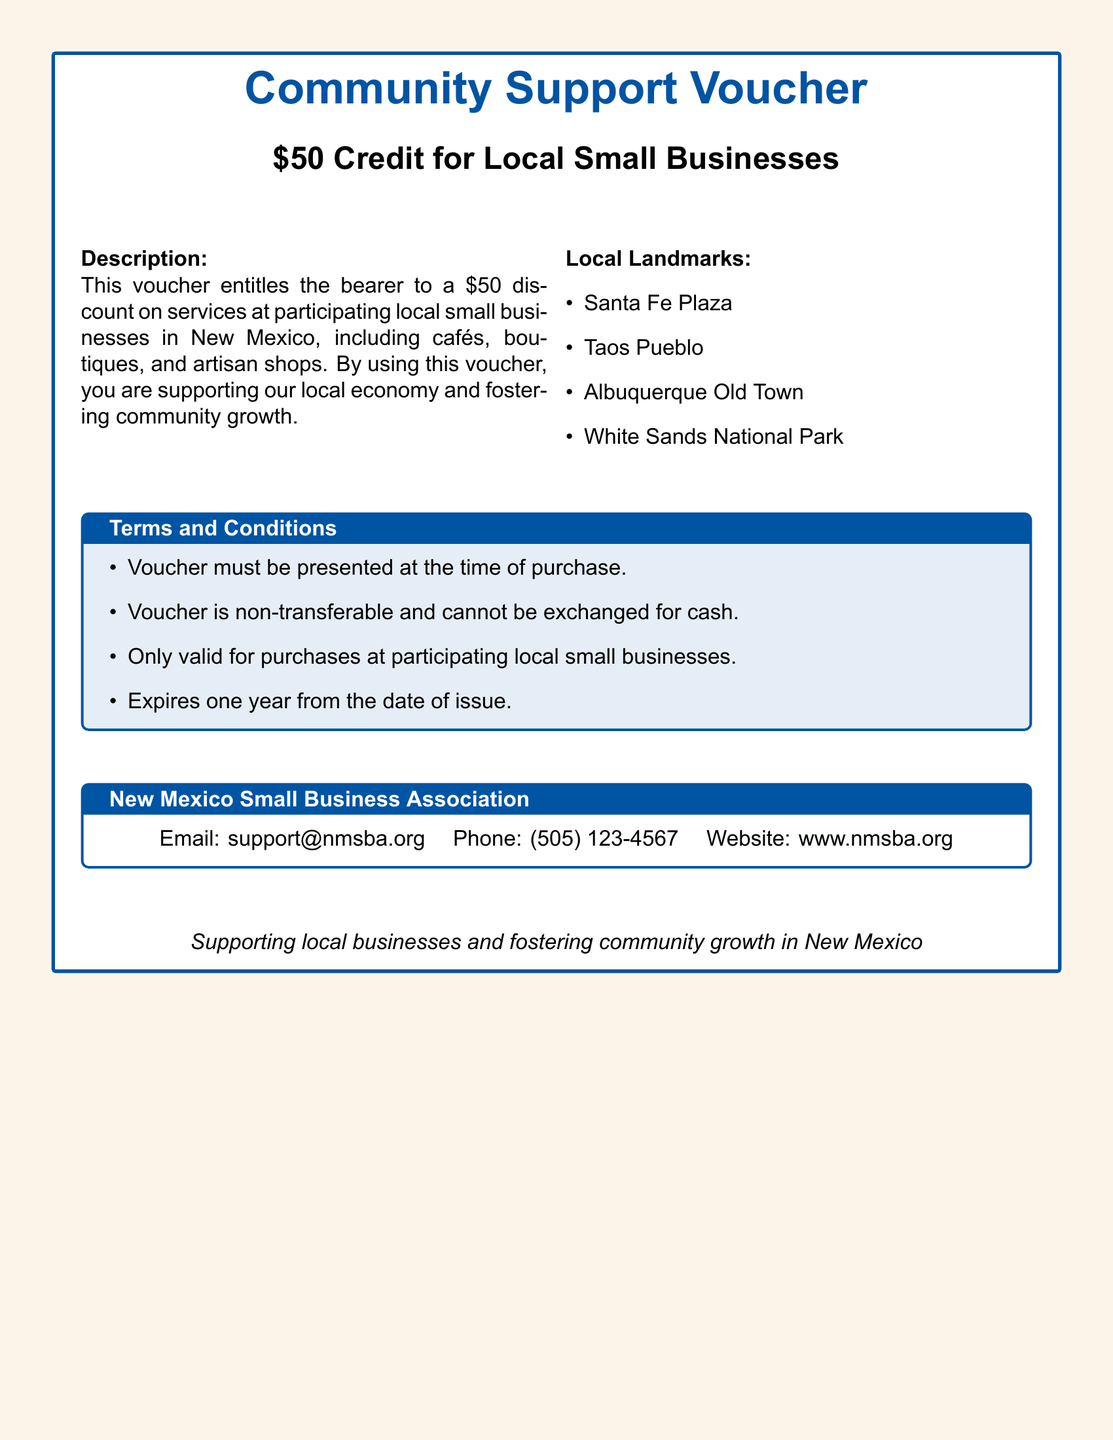What is the value of the voucher? The value of the voucher is stated clearly in the title as a $50 credit for local small businesses.
Answer: $50 What is the primary purpose of the voucher? The document describes that the voucher is meant to support local economies and foster community growth by providing a discount on services.
Answer: Supporting local businesses Which types of businesses can accept this voucher? The document lists that participating businesses include cafés, boutiques, and artisan shops.
Answer: Cafés, boutiques, and artisan shops What is one local landmark mentioned in the document? The document includes a list of local landmarks, including Santa Fe Plaza as one of the options.
Answer: Santa Fe Plaza What is the expiration time frame for the voucher? The terms state that the voucher expires one year from the date of issue.
Answer: One year Who should you contact for support regarding the voucher? The New Mexico Small Business Association's contact information is provided for support regarding the voucher.
Answer: New Mexico Small Business Association What should be done with the voucher at the time of purchase? The terms state that the voucher must be presented at the time of purchase.
Answer: Presented Is the voucher transferable? According to the terms, the voucher is explicitly stated to be non-transferable.
Answer: Non-transferable What color scheme is used in the document? The document uses nmblue and nmsand colors prominently throughout its design.
Answer: nmblue and nmsand 